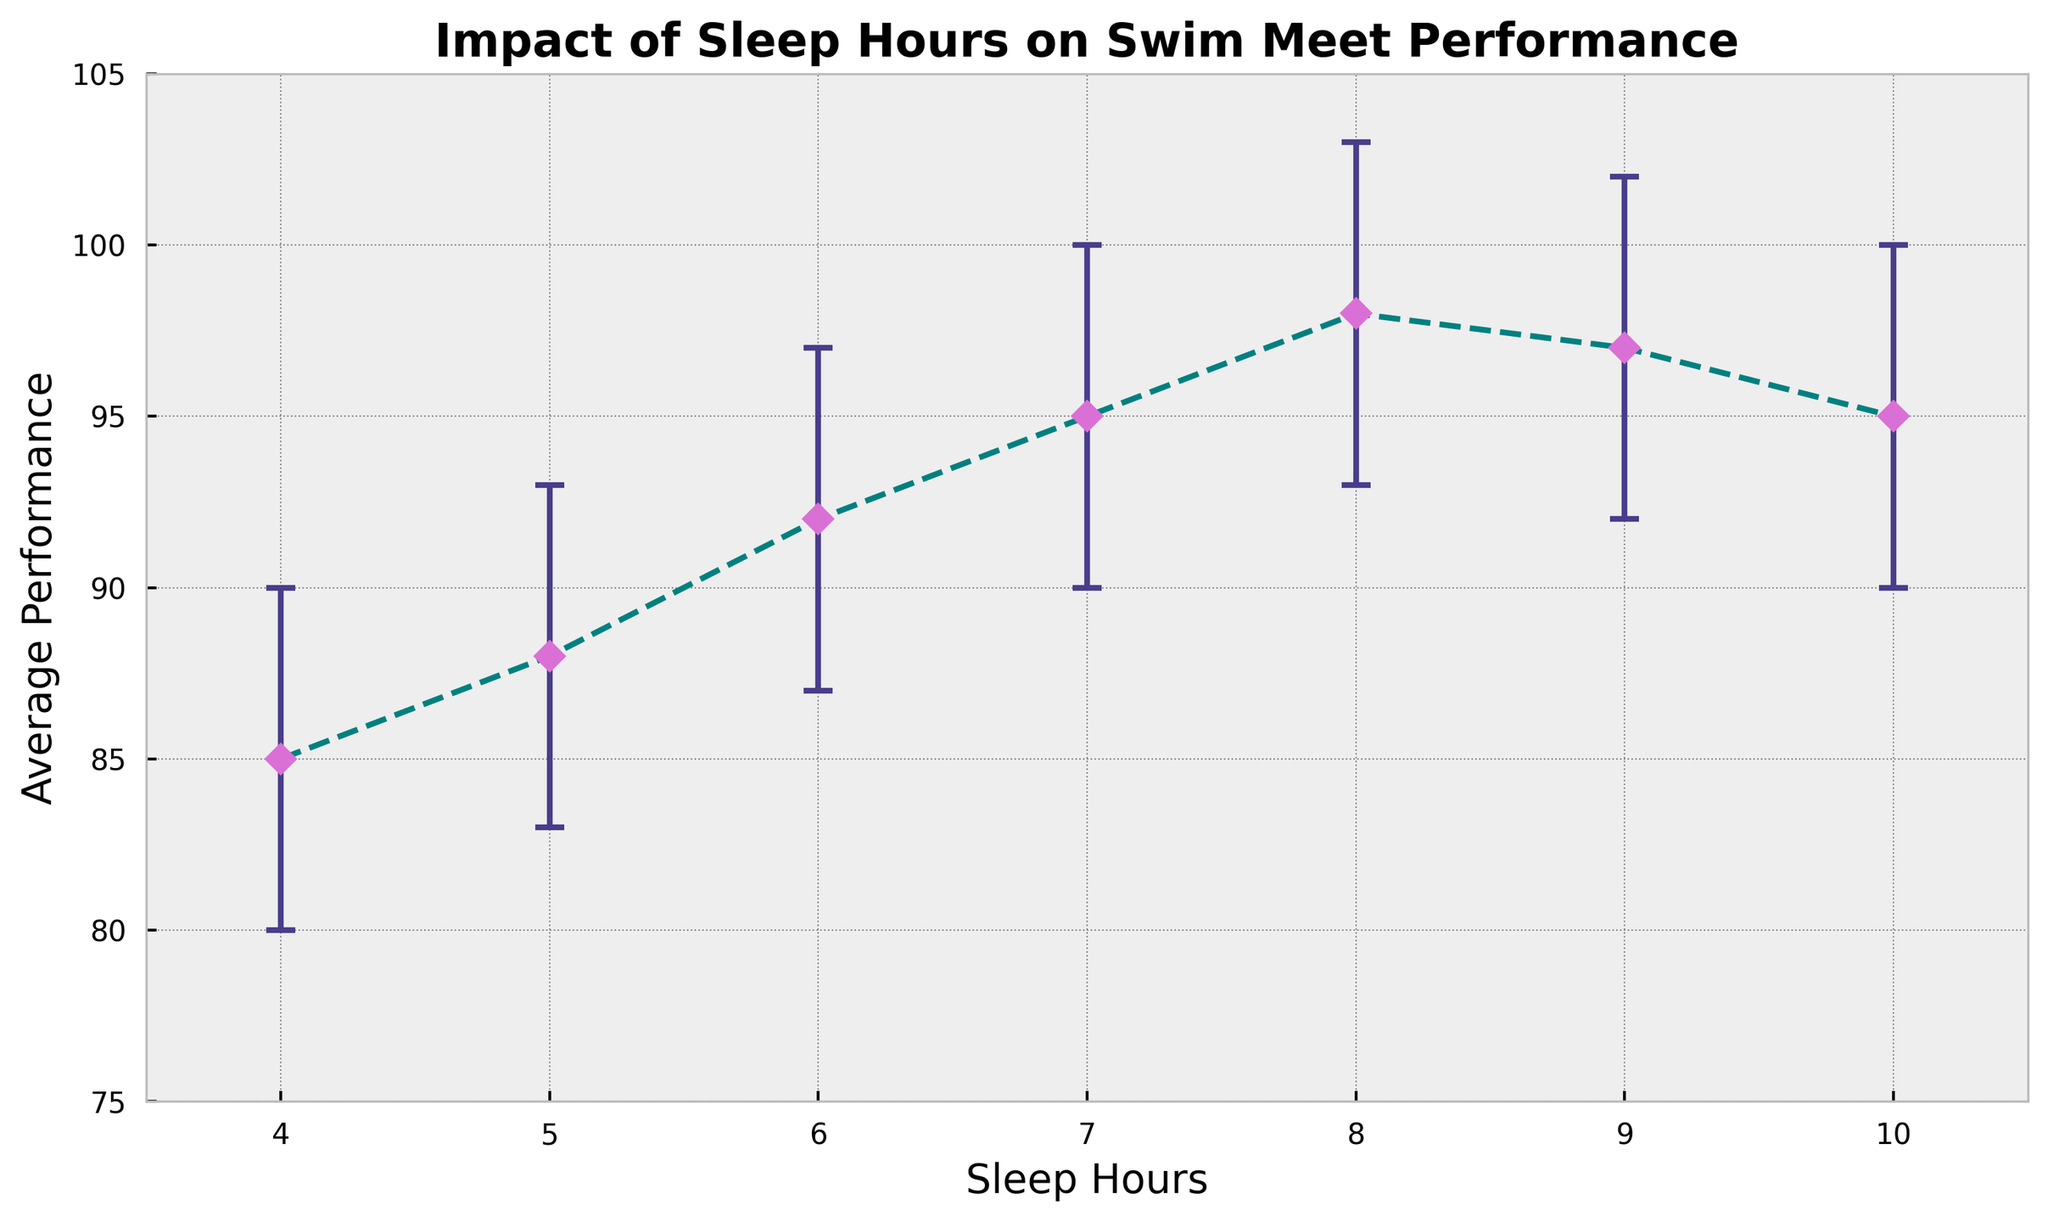Which sleep hour has the highest average performance? By examining the chart, locate the sleep hour corresponding to the highest data point on the average performance axis. The highest data point is at 8 sleep hours.
Answer: 8 hours How much does the average performance increase from 4 hours to 7 hours of sleep? Subtract the performance at 4 hours (85) from the performance at 7 hours (95). The difference is 95 - 85.
Answer: 10 points Do any of the sleep hours have overlapping confidence intervals? Visually inspect the confidence intervals indicated by the error bars on the chart to see if they intersect with each other. Sleep hours 6, 7, and 8 have overlapping confidence intervals.
Answer: Yes Which sleep hour has the largest confidence interval? Calculate the length of the confidence intervals by subtracting the lower confidence interval from the upper confidence interval for each sleep hour. The largest difference is for 8 hours (103 - 93 = 10).
Answer: 8 hours Between 9 and 10 hours of sleep, which has a higher average performance value? Compare the average performance values at 9 hours (97) and 10 hours (95). 9 hours is higher.
Answer: 9 hours What is the average performance at 6 hours of sleep in terms of lower and upper confidence interval? At 6 hours of sleep, locate the lower CI (87) and upper CI (97) on the chart. The performance is within this range.
Answer: Between 87 and 97 What is the difference in average performance between 8 hours of sleep and 10 hours of sleep? Subtract the average performance at 10 hours (95) from the performance at 8 hours (98). The difference is 98 - 95.
Answer: 3 points Which sleep hours show a decrease in average performance after reaching the peak? Identify the peak performance at 8 hours (98) and then see that performance values decrease at 9 and 10 hours (97 and 95 respectively).
Answer: 9 and 10 hours Is the confidence interval for 5 hours of sleep wider than that for 7 hours? Compare the lengths of the confidence intervals: 5 hours (93 - 83 = 10) and 7 hours (100 - 90 = 10). Both are the same width but are visually different due to maximum points.
Answer: No 